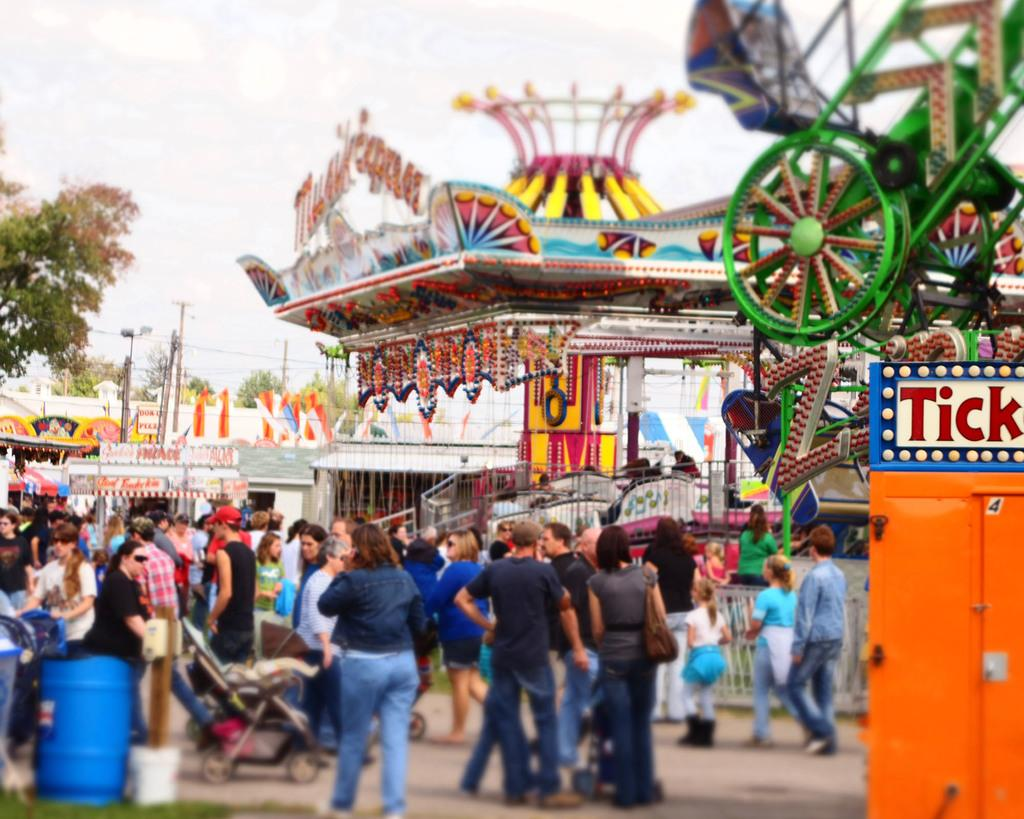How many people are in the image? There is a group of people in the image, but the exact number is not specified. What is on the ground near the group of people? There is a stroller on the ground in the image. What can be seen in the distance behind the group of people? There are buildings, trees, poles, and the sky visible in the background of the image. Are there any other objects in the background of the image? Yes, there are some unspecified objects in the background of the image. What type of leather is being used to make the horns in the image? There are no horns or leather present in the image. 